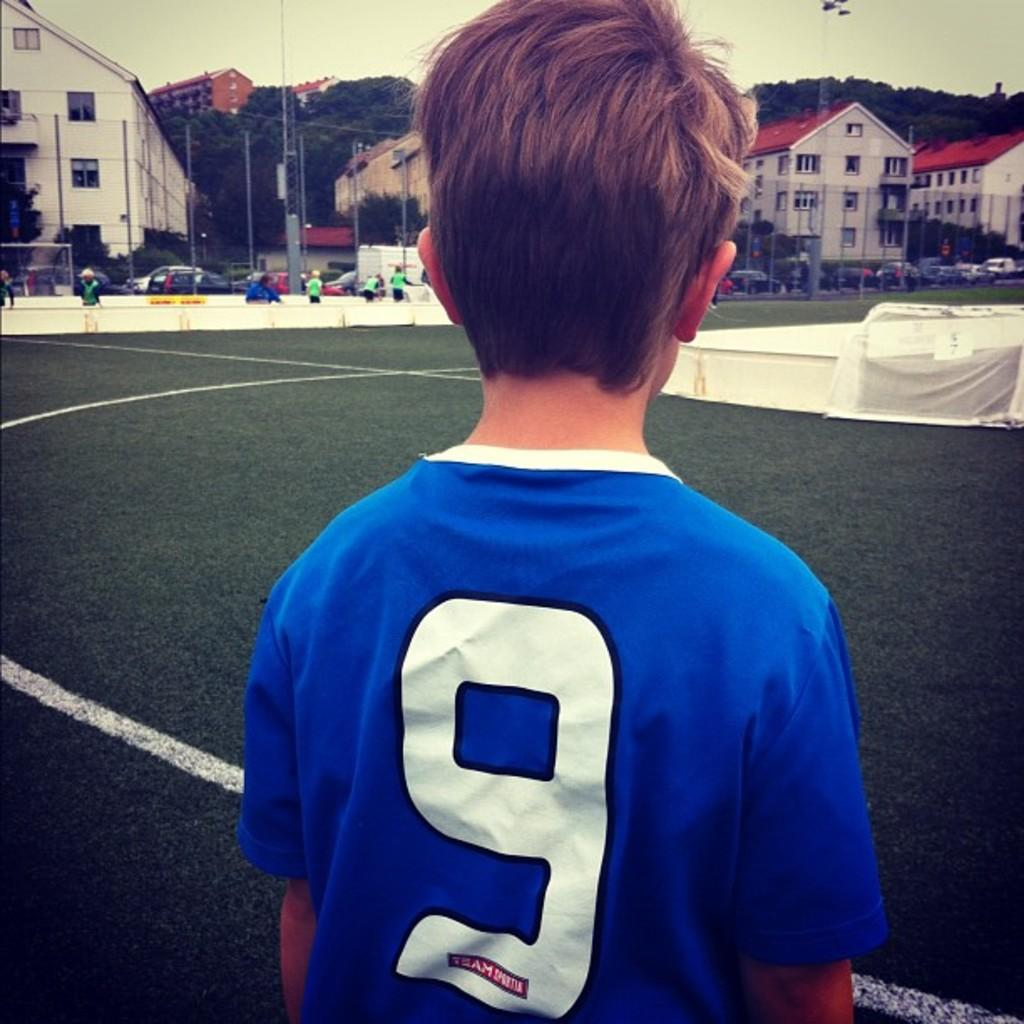Provide a one-sentence caption for the provided image. A little boy with the number 9 on the back of his shirt facing buildings with red roofs. 